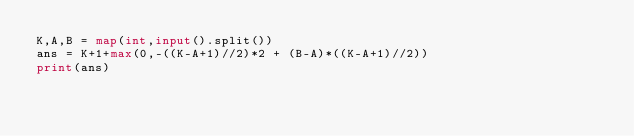<code> <loc_0><loc_0><loc_500><loc_500><_Python_>K,A,B = map(int,input().split())
ans = K+1+max(0,-((K-A+1)//2)*2 + (B-A)*((K-A+1)//2))
print(ans)</code> 